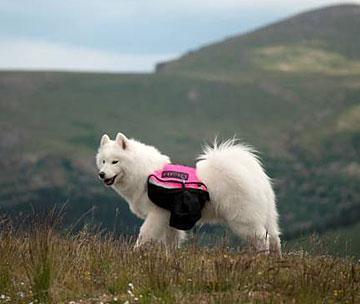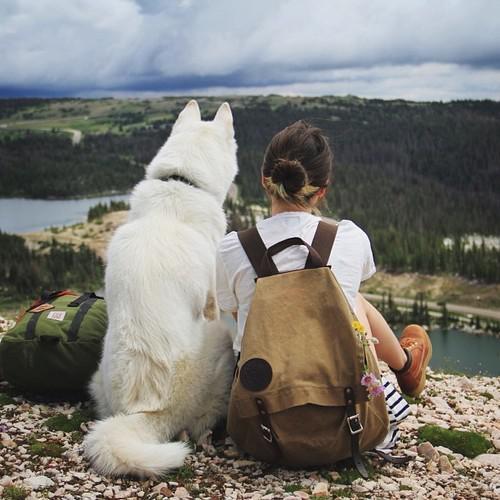The first image is the image on the left, the second image is the image on the right. For the images displayed, is the sentence "A white dog has a colored canvas bag strapped to its back in one image, while the other image is of multiple dogs with no bags." factually correct? Answer yes or no. No. The first image is the image on the left, the second image is the image on the right. Examine the images to the left and right. Is the description "An image shows a rightward facing dog wearing a pack." accurate? Answer yes or no. No. 